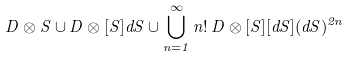Convert formula to latex. <formula><loc_0><loc_0><loc_500><loc_500>D \otimes S \cup D \otimes [ S ] d S \cup \bigcup _ { n = 1 } ^ { \infty } n ! \, D \otimes [ S ] [ d S ] ( d S ) ^ { 2 n }</formula> 